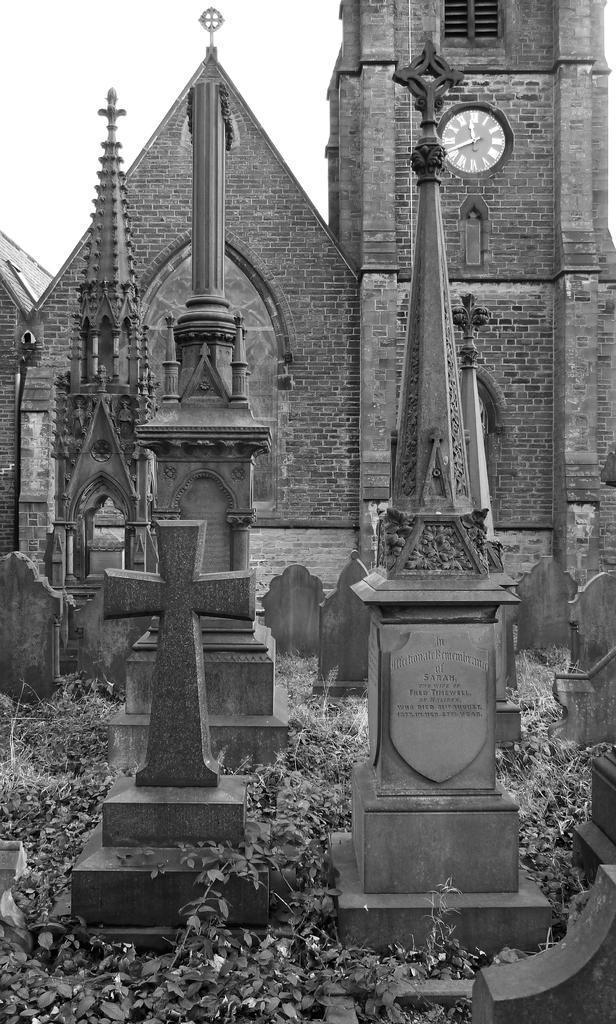Could you give a brief overview of what you see in this image? Black and white picture. Here we can see memorial walls. Background there is a brick wall. On this brick wall there is a clock. Here we can see a window. 